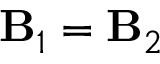Convert formula to latex. <formula><loc_0><loc_0><loc_500><loc_500>B _ { 1 } = B _ { 2 }</formula> 